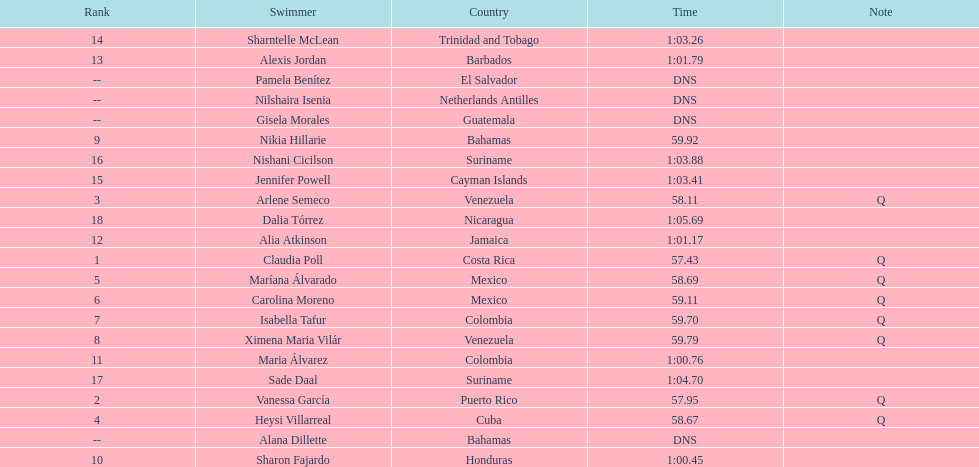How many competitors did not start the preliminaries? 4. 